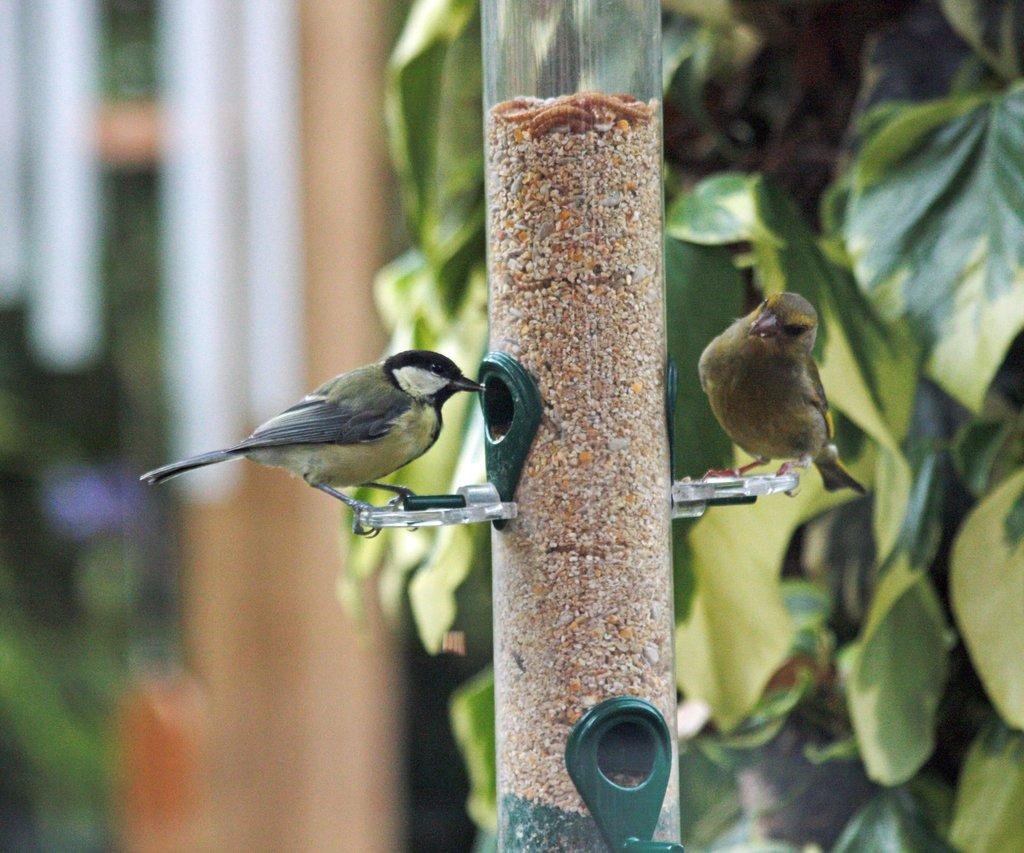How many birds can be seen in the image? There are two birds in the image. What is the object that the birds are perched on? There is a pole in the image that the birds are perched on. What type of vegetation is on the right side of the image? There is a tree on the right side of the image. What can be seen in the distance behind the birds and the pole? There are buildings in the background of the image. How would you describe the appearance of the background in the image? The background of the image is blurred. Can you see the goose taking a breath in the image? There is no goose present in the image, and therefore no such action can be observed. 